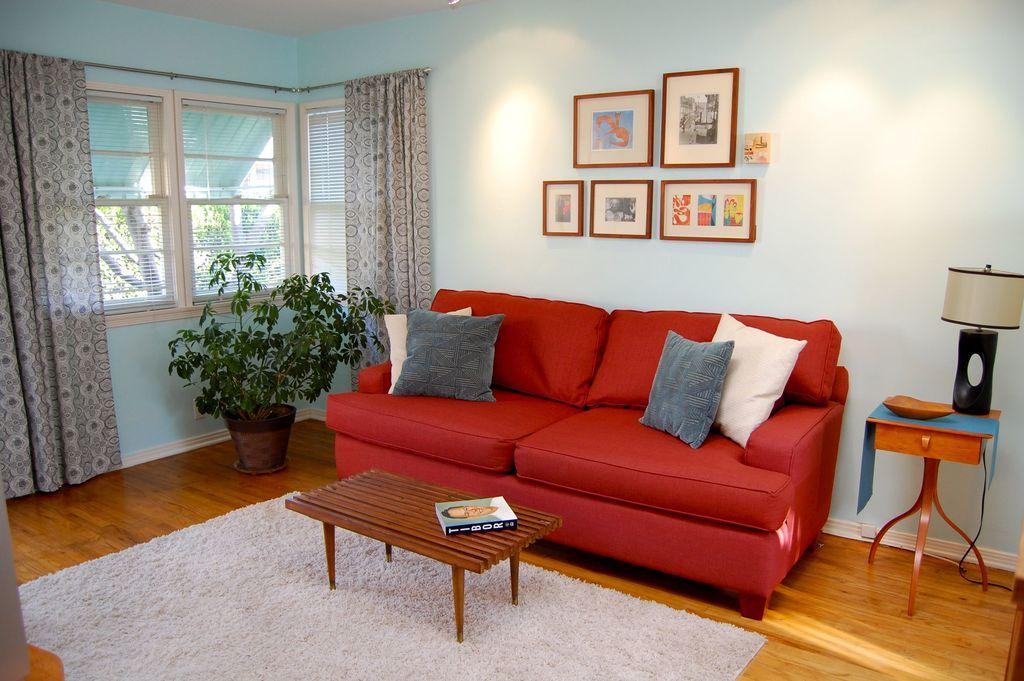Could you give a brief overview of what you see in this image? In the picture we can see a house , in the house we can see red colored sofa with pillows and two pillows on one side, just beside it there is a small table on it there is a lamp and to the left hand side to the sofa there is a house plant, near it there is a window with a curtain and also we can see a wall, on the wall we can see a table and book on it, it is on the floor mat, which is white in color. 